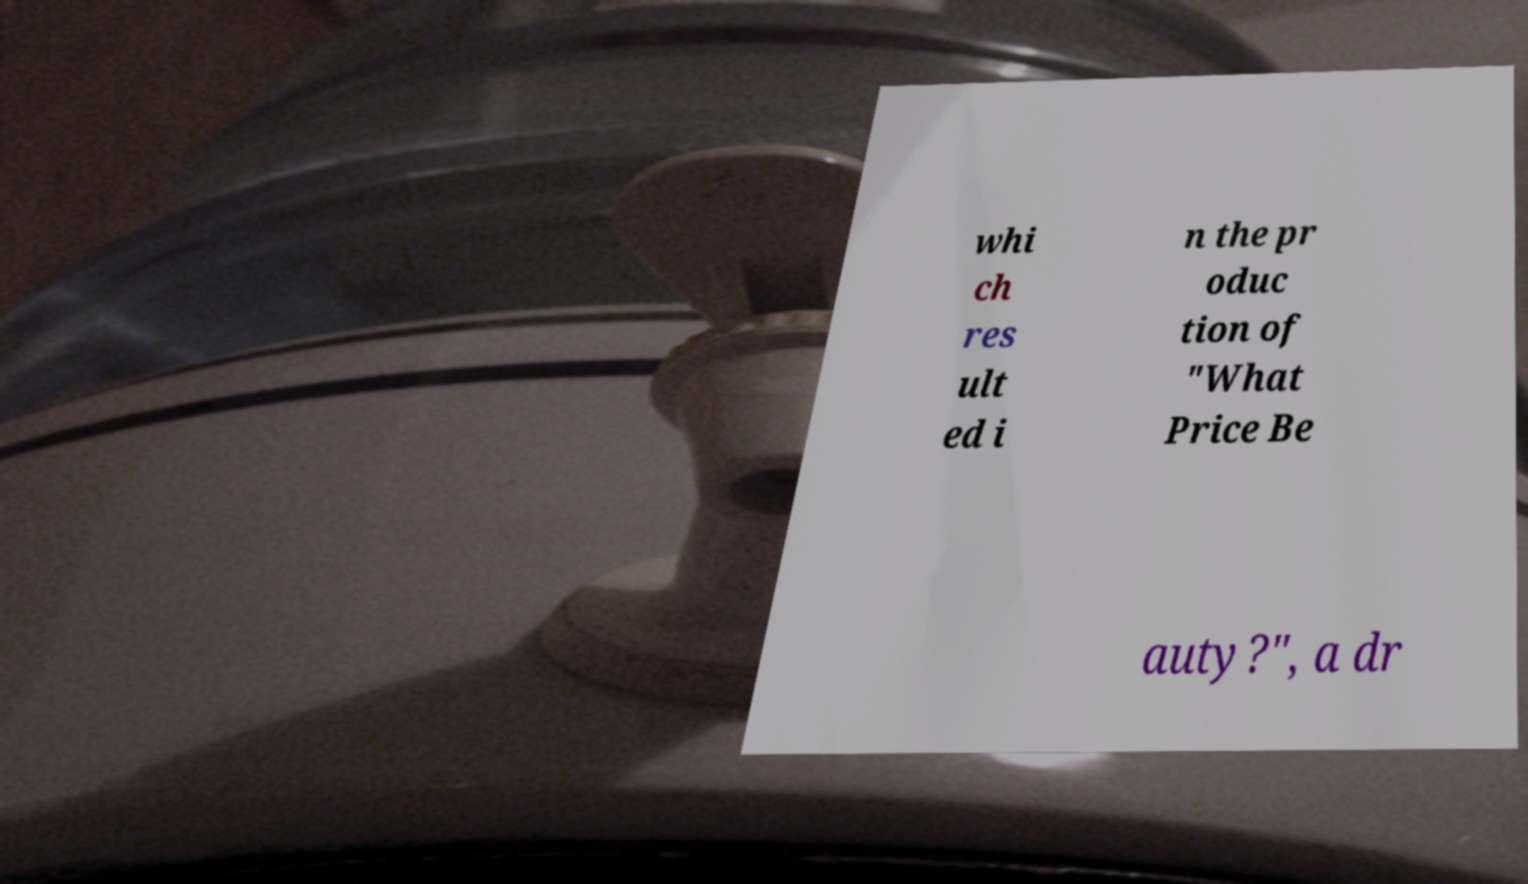For documentation purposes, I need the text within this image transcribed. Could you provide that? whi ch res ult ed i n the pr oduc tion of "What Price Be auty?", a dr 